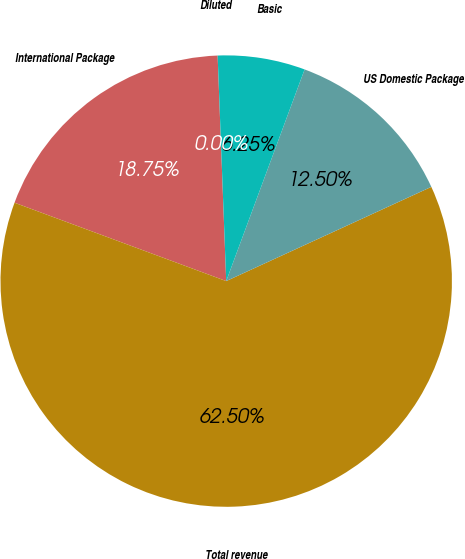Convert chart. <chart><loc_0><loc_0><loc_500><loc_500><pie_chart><fcel>International Package<fcel>Total revenue<fcel>US Domestic Package<fcel>Basic<fcel>Diluted<nl><fcel>18.75%<fcel>62.49%<fcel>12.5%<fcel>6.25%<fcel>0.0%<nl></chart> 